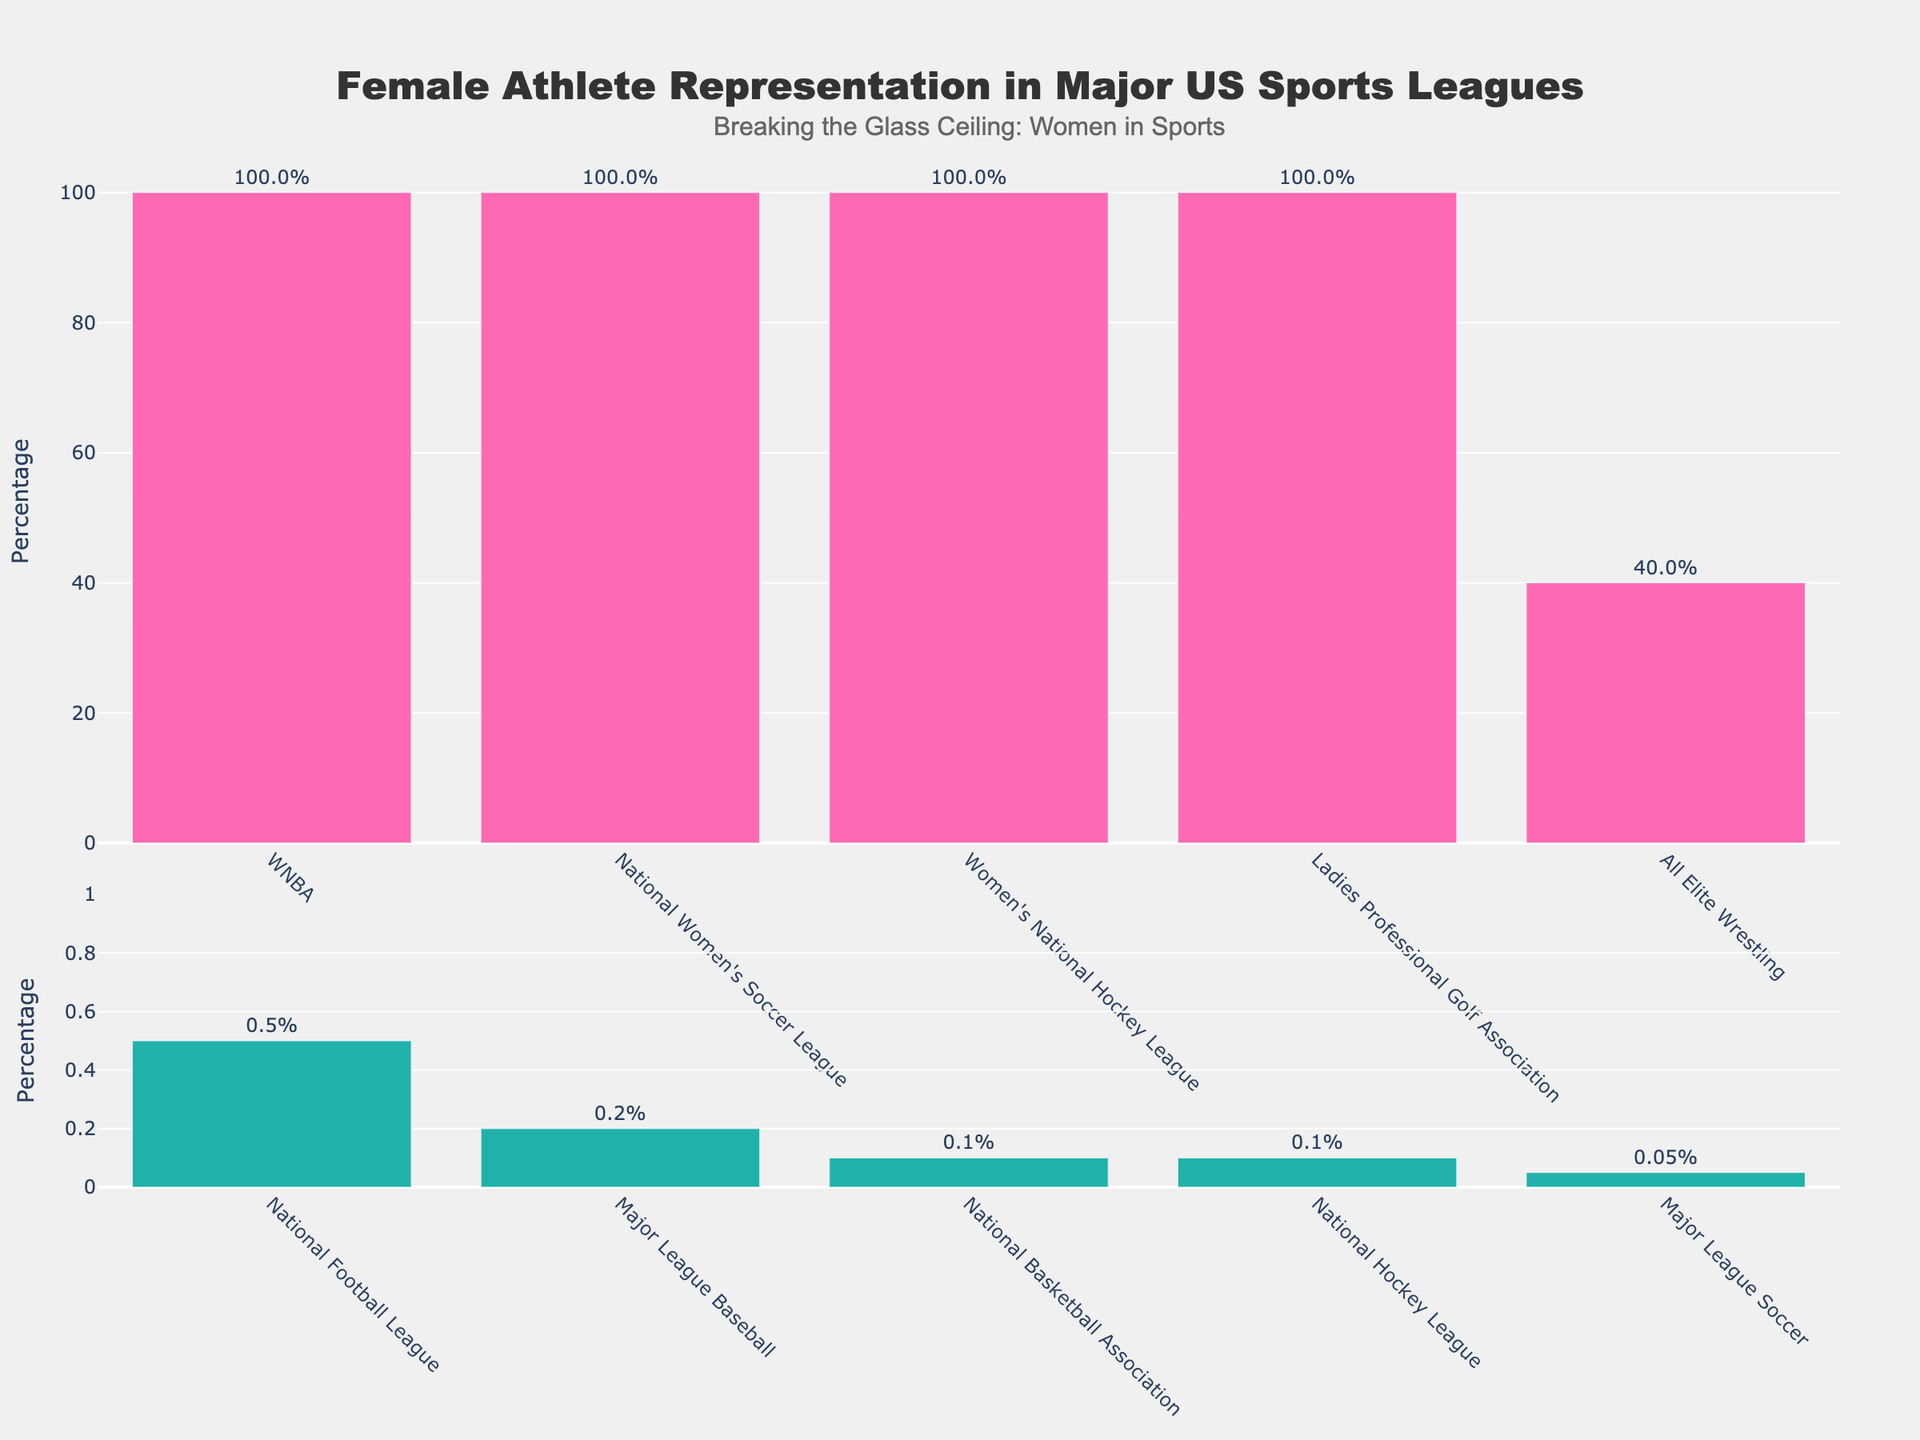What fraction of leagues have a high representation of female athletes? There are 5 leagues with 100% female athlete representation out of a total of 10 leagues. To find the fraction, divide the number of high representation leagues by the total number of leagues: 5/10.
Answer: 1/2 Which league has the lowest percentage of female athletes? By looking at the lower plot, the league with the lowest bar height (color green) is Major League Soccer at 0.05%.
Answer: Major League Soccer How much more is the representation of female athletes in the WNBA compared to the NFL? The WNBA has 100% female athlete representation, while the NFL has 0.5%. The difference is 100% - 0.5% = 99.5%.
Answer: 99.5% Which leagues fall under the low representation category and what are their percentages? By referring to the lower plot (colored green), the leagues are All Elite Wrestling (40%), National Football League (0.5%), Major League Baseball (0.2%), National Basketball Association (0.1%), National Hockey League (0.1%), and Major League Soccer (0.05%).
Answer: All Elite Wrestling (40%), NFL (0.5%), MLB (0.2%), NBA (0.1%), NHL (0.1%), MLS (0.05%) What is the median representation percentage of female athletes across all leagues? To find the median, list all percentages in ascending order: 0.05%, 0.1%, 0.1%, 0.2%, 0.5%, 40%, 100%, 100%, 100%, 100%. The median is the average of the 5th and 6th numbers: (0.5% + 40%) / 2 = 20.25%.
Answer: 20.25% Is the representation of female athletes in the Women’s National Hockey League greater than in Major League Baseball? The Women’s National Hockey League has 100% female athlete representation, while Major League Baseball has 0.2%. 100% is greater than 0.2%.
Answer: Yes What percentage of female athlete representation is considered high and low as per the visual distinction in the plots? High representation is indicated by the pink bars in the top plot (≥10%), and low representation is indicated by the green bars in the bottom plot (<10%).
Answer: High: ≥10%, Low: <10% How many leagues have a female athlete representation below 1%? By observing the lower plot (green bars), the leagues with representation below 1% are the NFL (0.5%), MLB (0.2%), NBA (0.1%), NHL (0.1%), and MLS (0.05%). There are 5 such leagues.
Answer: 5 Which league has the highest non-zero female athlete representation among major male-dominated sports leagues? The highest bar among the male-dominated leagues in the lower plot (green bars) is All Elite Wrestling at 40%.
Answer: All Elite Wrestling 